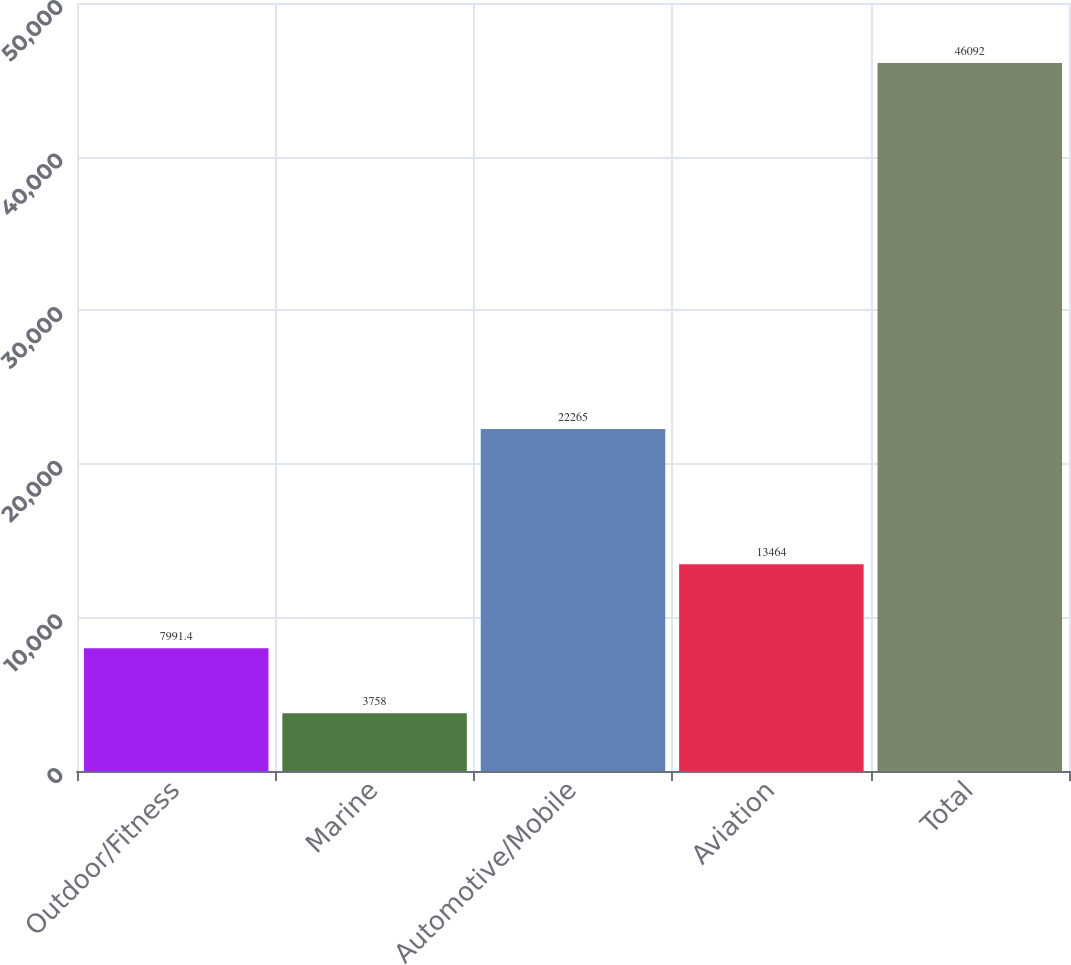<chart> <loc_0><loc_0><loc_500><loc_500><bar_chart><fcel>Outdoor/Fitness<fcel>Marine<fcel>Automotive/Mobile<fcel>Aviation<fcel>Total<nl><fcel>7991.4<fcel>3758<fcel>22265<fcel>13464<fcel>46092<nl></chart> 